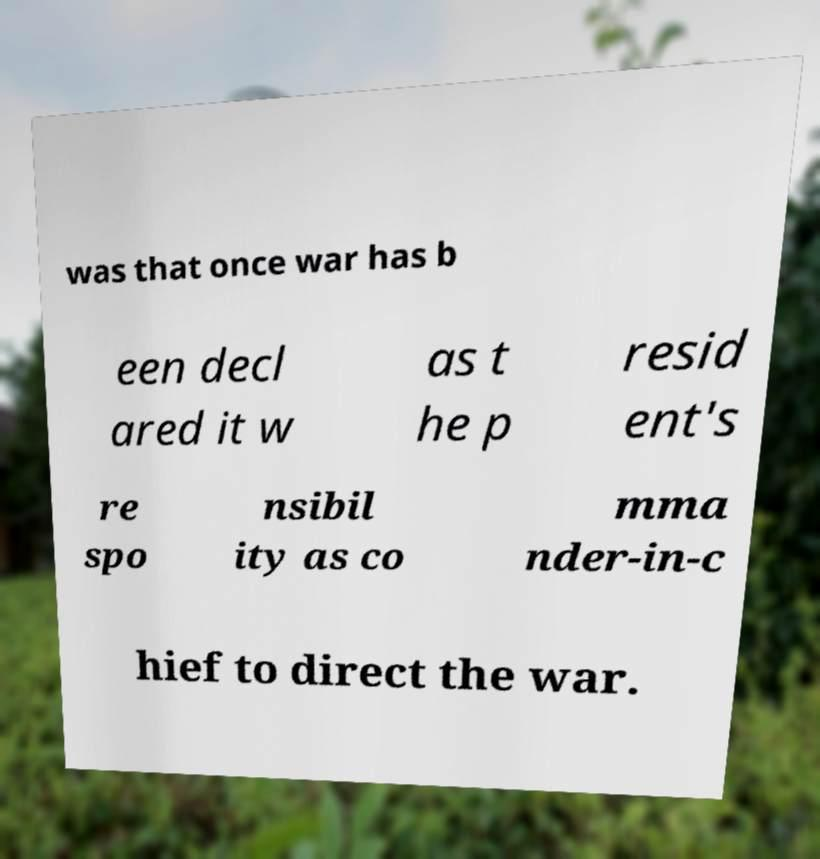For documentation purposes, I need the text within this image transcribed. Could you provide that? was that once war has b een decl ared it w as t he p resid ent's re spo nsibil ity as co mma nder-in-c hief to direct the war. 